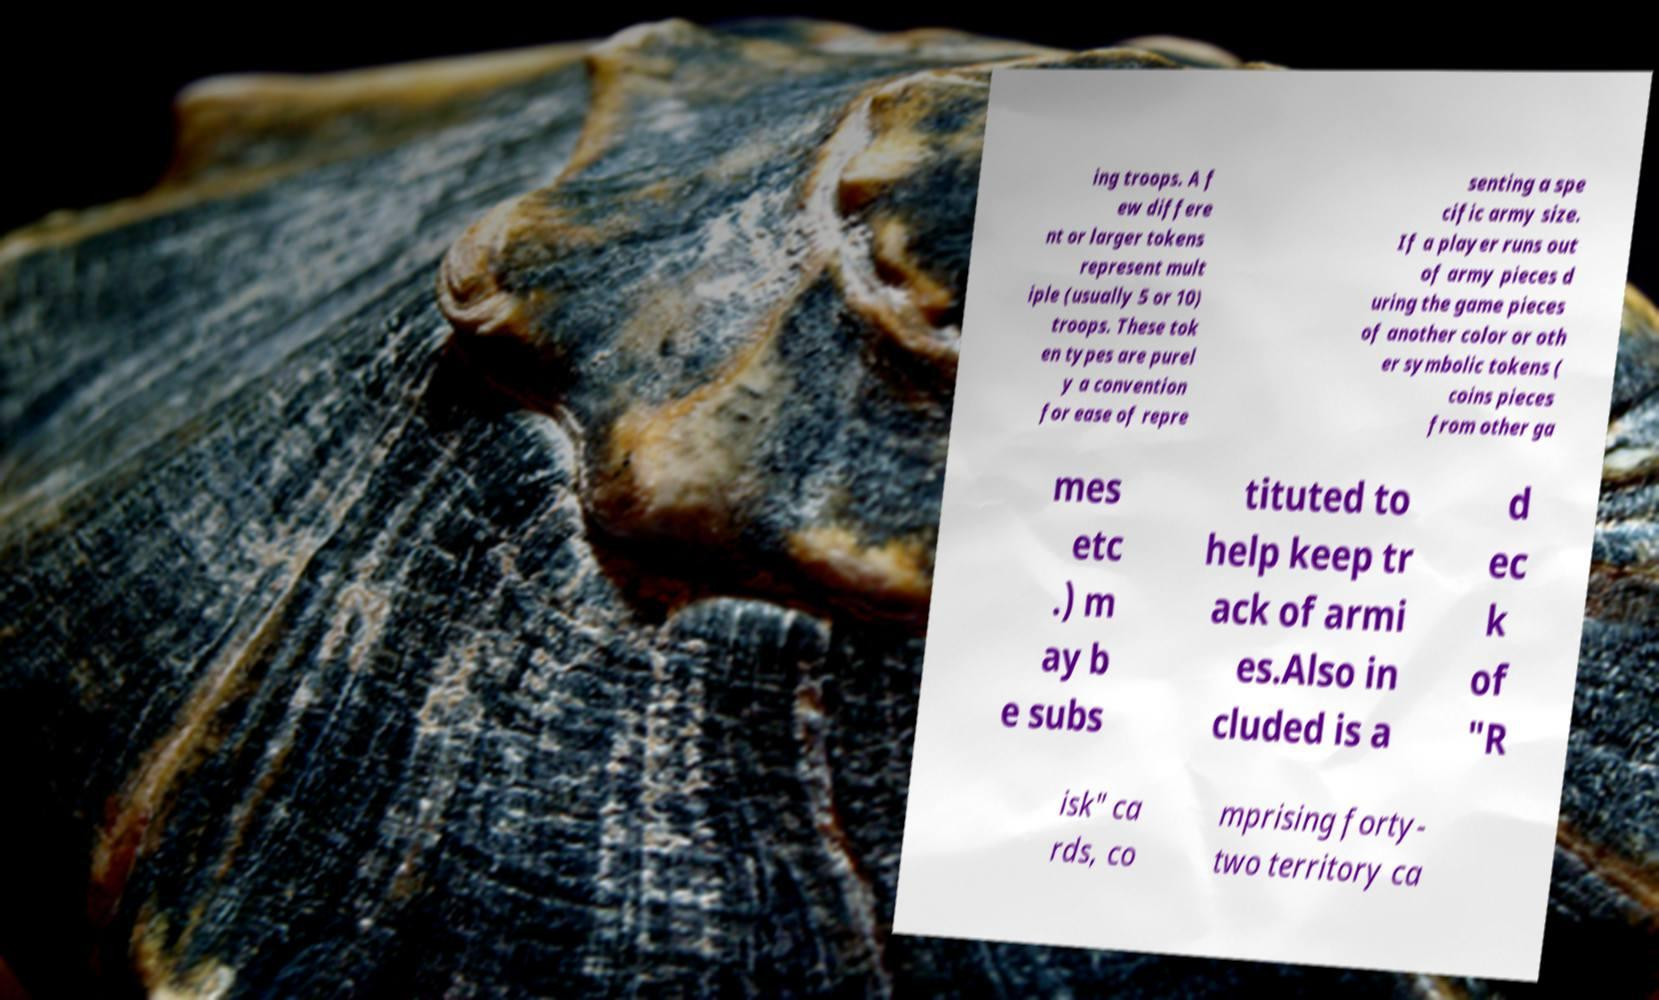Please read and relay the text visible in this image. What does it say? ing troops. A f ew differe nt or larger tokens represent mult iple (usually 5 or 10) troops. These tok en types are purel y a convention for ease of repre senting a spe cific army size. If a player runs out of army pieces d uring the game pieces of another color or oth er symbolic tokens ( coins pieces from other ga mes etc .) m ay b e subs tituted to help keep tr ack of armi es.Also in cluded is a d ec k of "R isk" ca rds, co mprising forty- two territory ca 